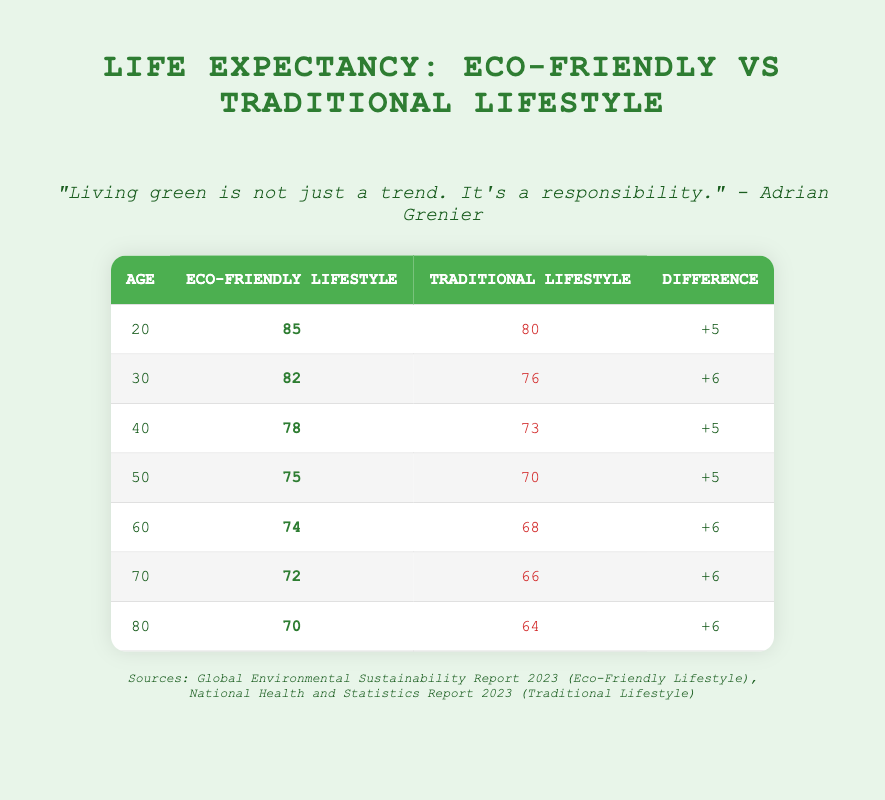What is the life expectancy at age 20 for individuals following an eco-friendly lifestyle? The table shows that for individuals at age 20 following an eco-friendly lifestyle, the life expectancy is listed as 85 years.
Answer: 85 What is the life expectancy difference at age 60 between eco-friendly and traditional lifestyles? For age 60, the life expectancy for the eco-friendly lifestyle is 74 years, and for the traditional lifestyle, it is 68 years. The difference is calculated as 74 - 68 = 6 years.
Answer: 6 Is the life expectancy for a 50-year-old adopting a traditional lifestyle lower than that of a 60-year-old adopting an eco-friendly lifestyle? The life expectancy for a 50-year-old traditional lifestyle is 70 years, while for a 60-year-old eco-friendly lifestyle, it is 74 years. Since 70 years is less than 74 years, the statement is true.
Answer: Yes What is the average life expectancy for individuals following an eco-friendly lifestyle across all ages listed? To find the average life expectancy for the eco-friendly lifestyle, we add all the life expectancy values (85 + 82 + 78 + 75 + 74 + 72 + 70 = 536) and divide by the number of entries (7). The average is calculated as 536 / 7 ≈ 76.57.
Answer: 76.57 Which age group shows the highest life expectancy difference between eco-friendly and traditional lifestyles? To find the age group with the highest life expectancy difference, we examine the differences: At age 20, the difference is 5 years, at 30 it is 6 years, at 40 it is 5 years, at 50 it is 5 years, at 60 it is 6 years, at 70 it is 6 years, and at 80 it is 6 years. The highest difference of 6 years applies to ages 30, 60, 70, and 80.
Answer: 30, 60, 70, 80 What is the trend in life expectancy for both lifestyles as age increases? For the eco-friendly lifestyle, life expectancy decreases from 85 at age 20 to 70 at age 80. For the traditional lifestyle, it decreases from 80 at age 20 to 64 at age 80. Both lifestyles show a declining trend in life expectancy with increasing age.
Answer: Declining trend 